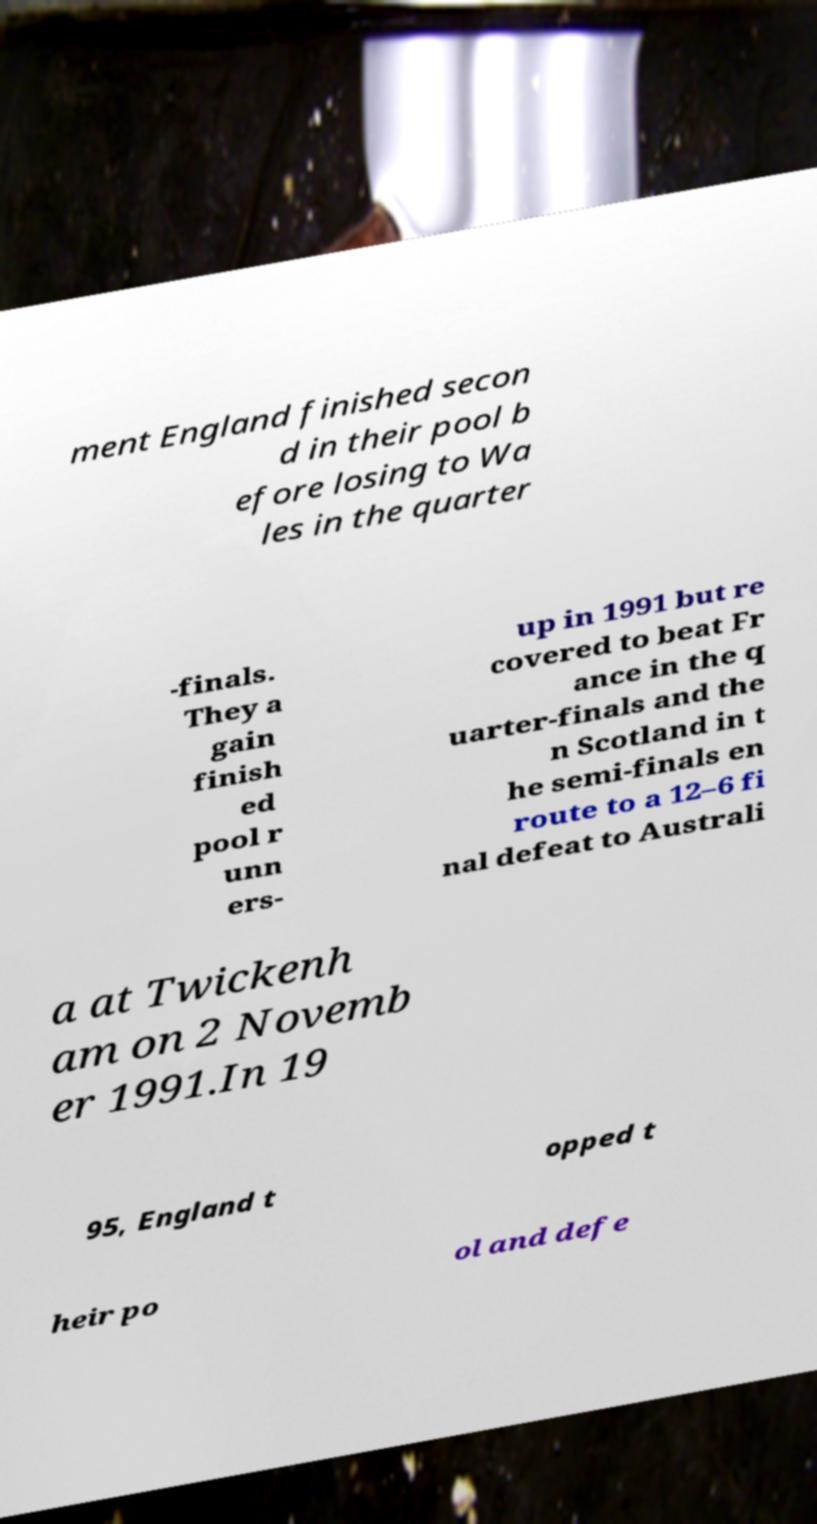Could you assist in decoding the text presented in this image and type it out clearly? ment England finished secon d in their pool b efore losing to Wa les in the quarter -finals. They a gain finish ed pool r unn ers- up in 1991 but re covered to beat Fr ance in the q uarter-finals and the n Scotland in t he semi-finals en route to a 12–6 fi nal defeat to Australi a at Twickenh am on 2 Novemb er 1991.In 19 95, England t opped t heir po ol and defe 